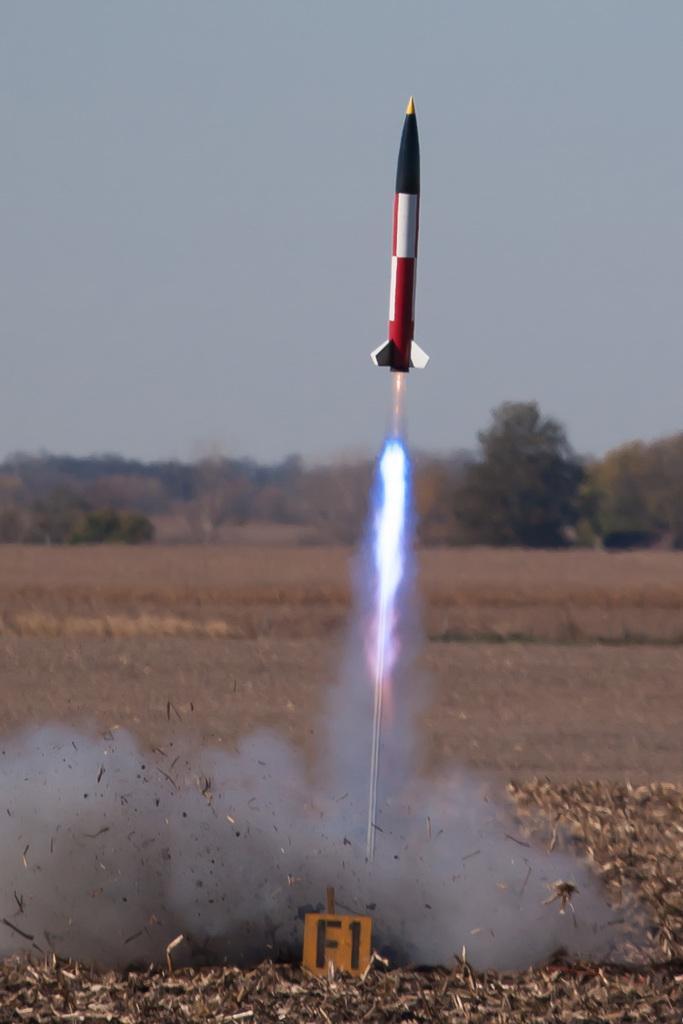Can you describe this image briefly? In the picture there is a rocket being fired up into the sky and on the ground the land is filled with dry leaves and in the background there are few trees. 